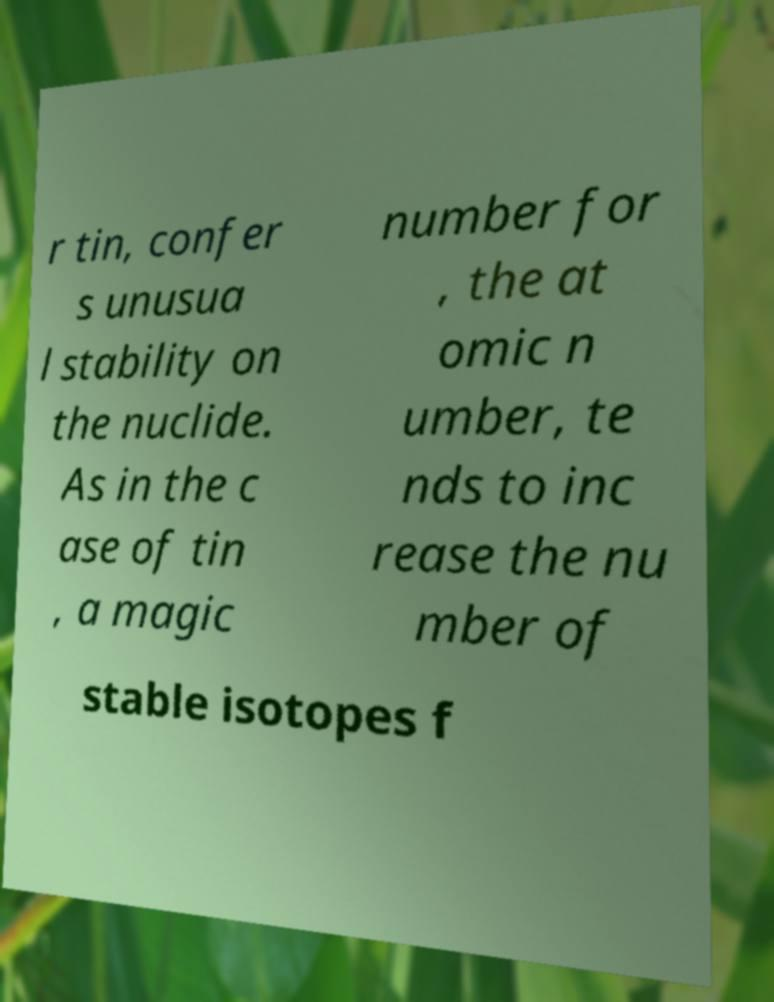Please read and relay the text visible in this image. What does it say? r tin, confer s unusua l stability on the nuclide. As in the c ase of tin , a magic number for , the at omic n umber, te nds to inc rease the nu mber of stable isotopes f 